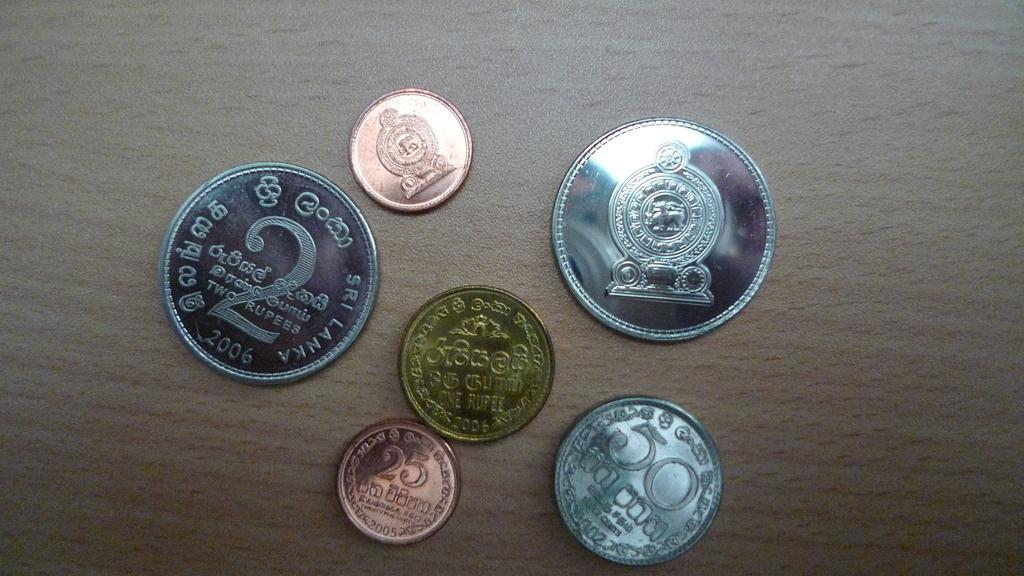<image>
Offer a succinct explanation of the picture presented. Six coins on a table, including one with a 2, one with a 50, and one with 25. 